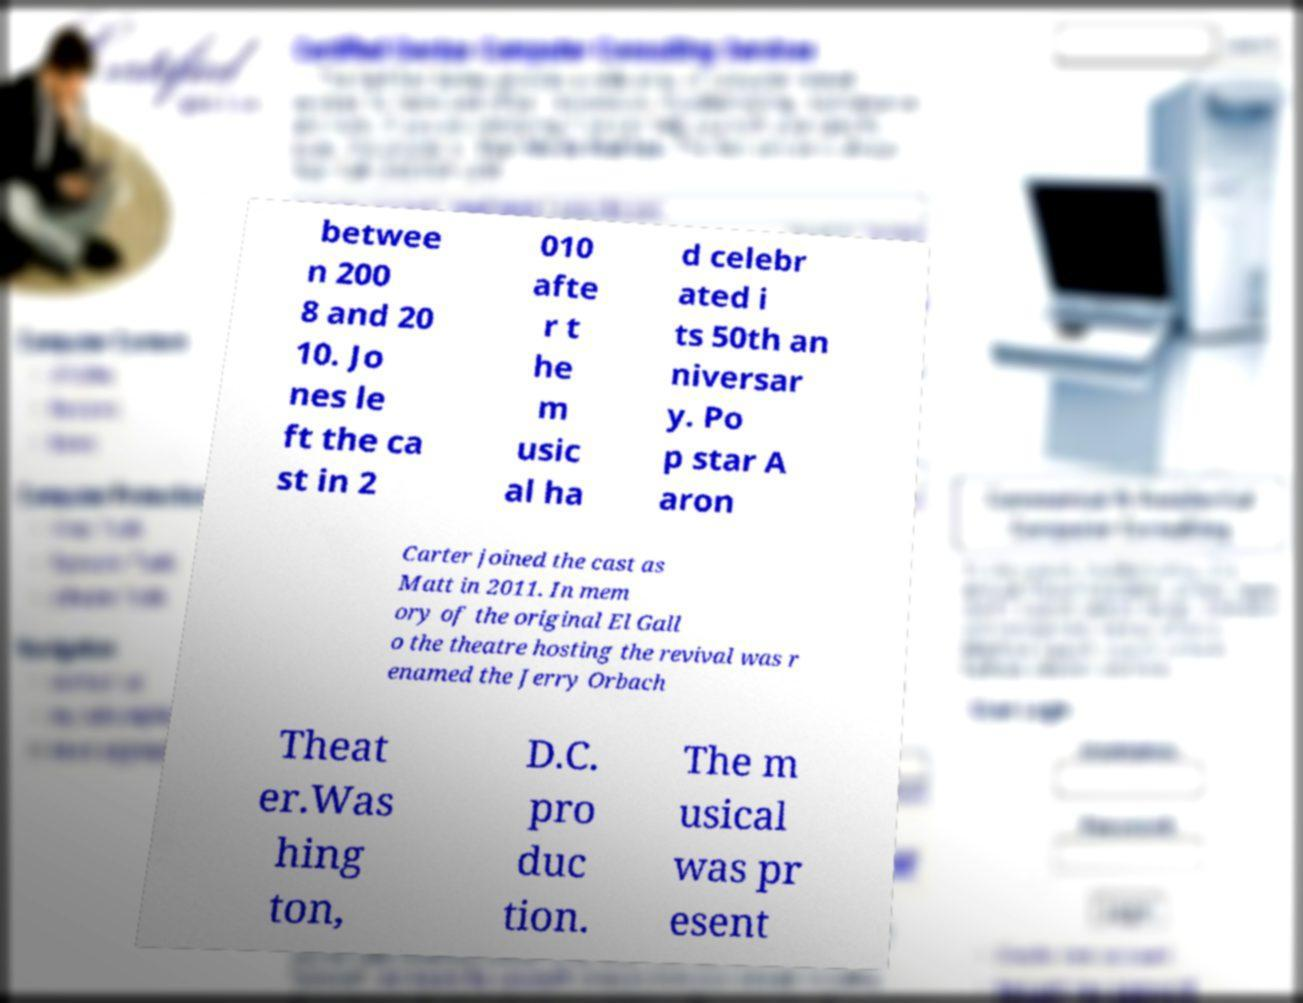Could you extract and type out the text from this image? betwee n 200 8 and 20 10. Jo nes le ft the ca st in 2 010 afte r t he m usic al ha d celebr ated i ts 50th an niversar y. Po p star A aron Carter joined the cast as Matt in 2011. In mem ory of the original El Gall o the theatre hosting the revival was r enamed the Jerry Orbach Theat er.Was hing ton, D.C. pro duc tion. The m usical was pr esent 